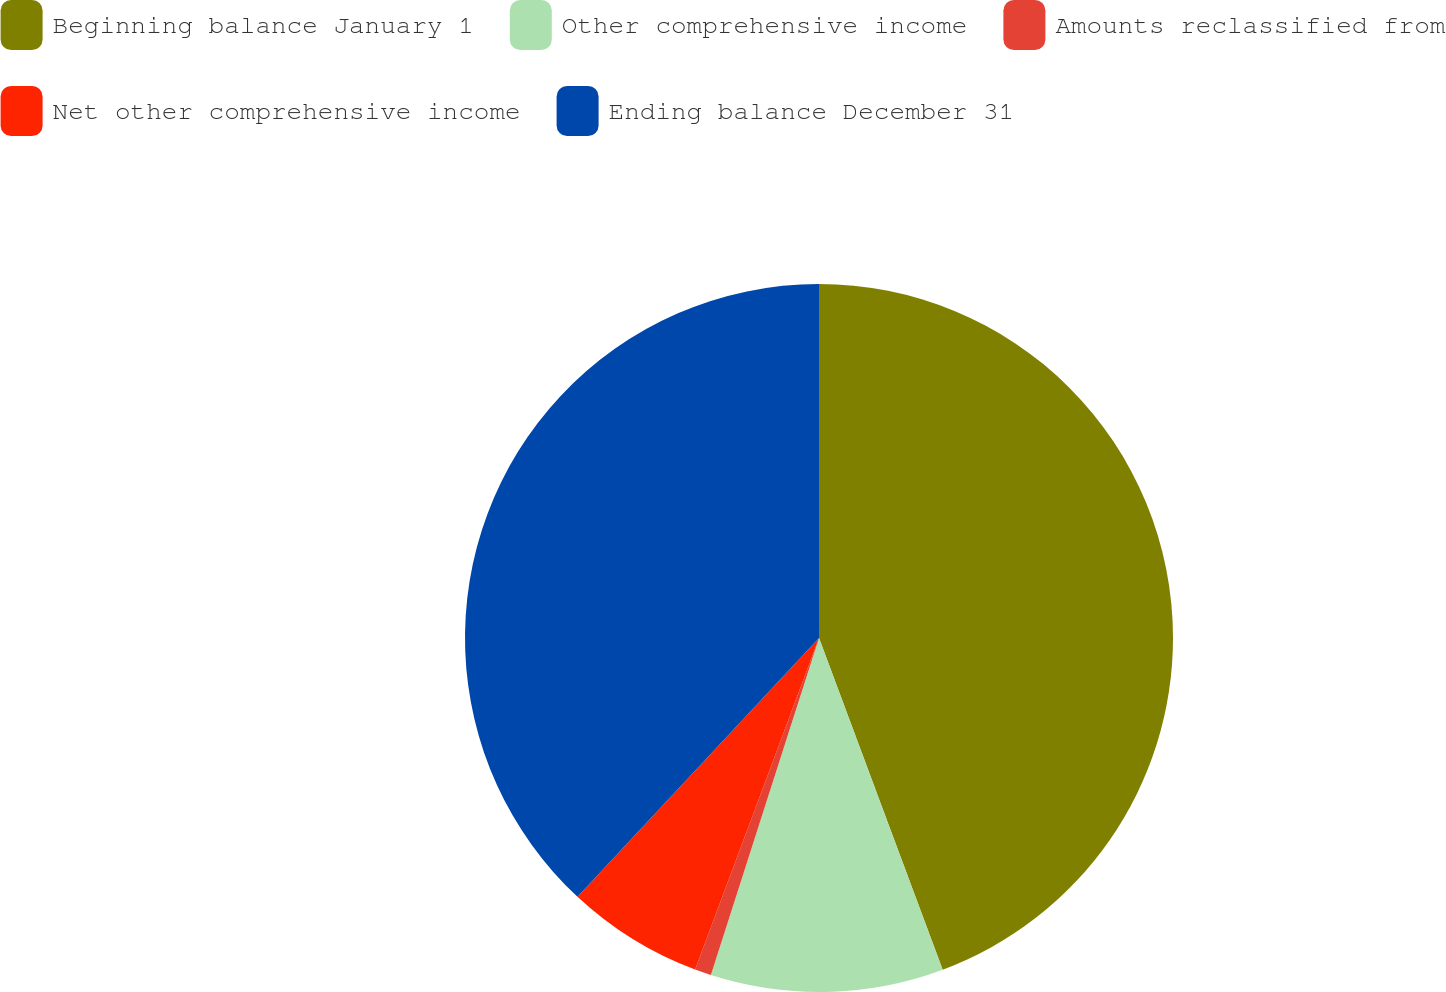<chart> <loc_0><loc_0><loc_500><loc_500><pie_chart><fcel>Beginning balance January 1<fcel>Other comprehensive income<fcel>Amounts reclassified from<fcel>Net other comprehensive income<fcel>Ending balance December 31<nl><fcel>44.32%<fcel>10.62%<fcel>0.75%<fcel>6.26%<fcel>38.05%<nl></chart> 